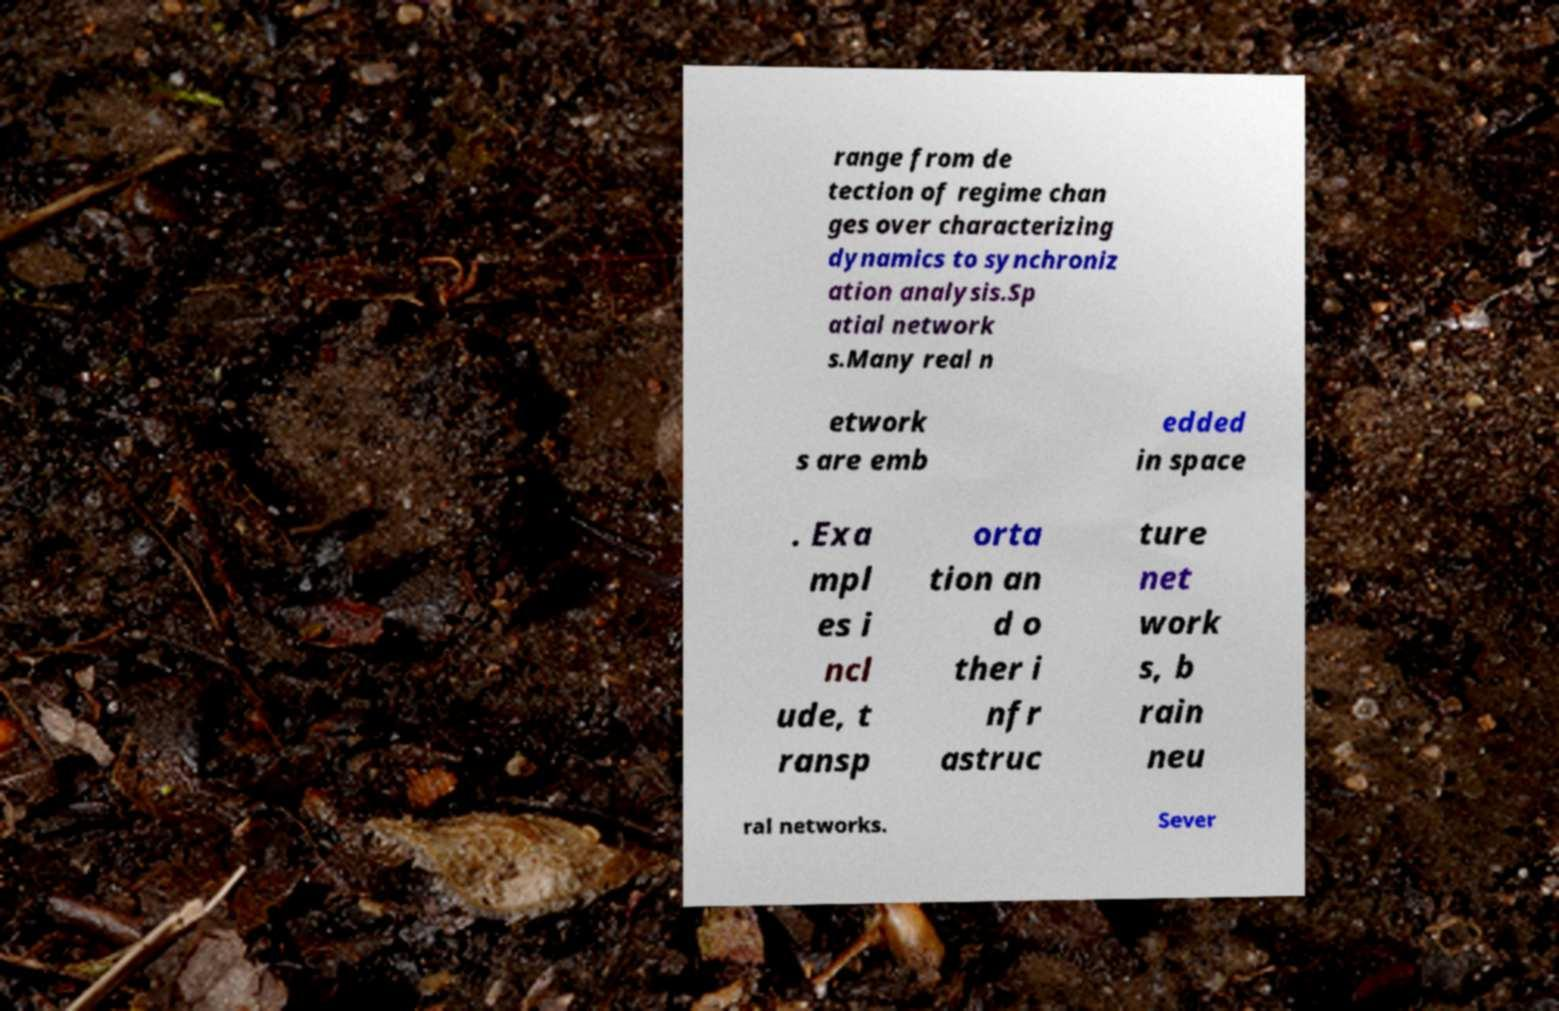There's text embedded in this image that I need extracted. Can you transcribe it verbatim? range from de tection of regime chan ges over characterizing dynamics to synchroniz ation analysis.Sp atial network s.Many real n etwork s are emb edded in space . Exa mpl es i ncl ude, t ransp orta tion an d o ther i nfr astruc ture net work s, b rain neu ral networks. Sever 